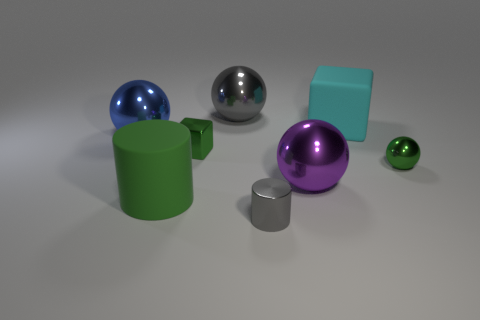What is the material of the big blue object that is the same shape as the large gray thing?
Offer a terse response. Metal. Are there more large cyan matte cubes on the left side of the green matte cylinder than small green shiny things on the left side of the purple ball?
Offer a very short reply. No. What is the color of the small object that is the same shape as the big gray shiny object?
Offer a terse response. Green. There is a cylinder right of the large green cylinder; does it have the same color as the big cylinder?
Provide a succinct answer. No. How many small cyan rubber things are there?
Make the answer very short. 0. Does the purple thing right of the gray metallic cylinder have the same material as the big blue thing?
Offer a terse response. Yes. Is there any other thing that is made of the same material as the gray ball?
Make the answer very short. Yes. There is a gray metallic thing that is in front of the big rubber thing on the right side of the large matte cylinder; what number of tiny shiny balls are in front of it?
Offer a terse response. 0. The green cylinder is what size?
Ensure brevity in your answer.  Large. Is the color of the rubber cylinder the same as the tiny metal cylinder?
Your answer should be very brief. No. 